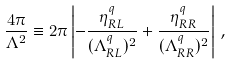<formula> <loc_0><loc_0><loc_500><loc_500>\frac { 4 \pi } { \Lambda ^ { 2 } } \equiv 2 \pi \left | - \frac { \eta ^ { q } _ { R L } } { ( \Lambda ^ { q } _ { R L } ) ^ { 2 } } + \frac { \eta ^ { q } _ { R R } } { ( \Lambda ^ { q } _ { R R } ) ^ { 2 } } \right | \, ,</formula> 